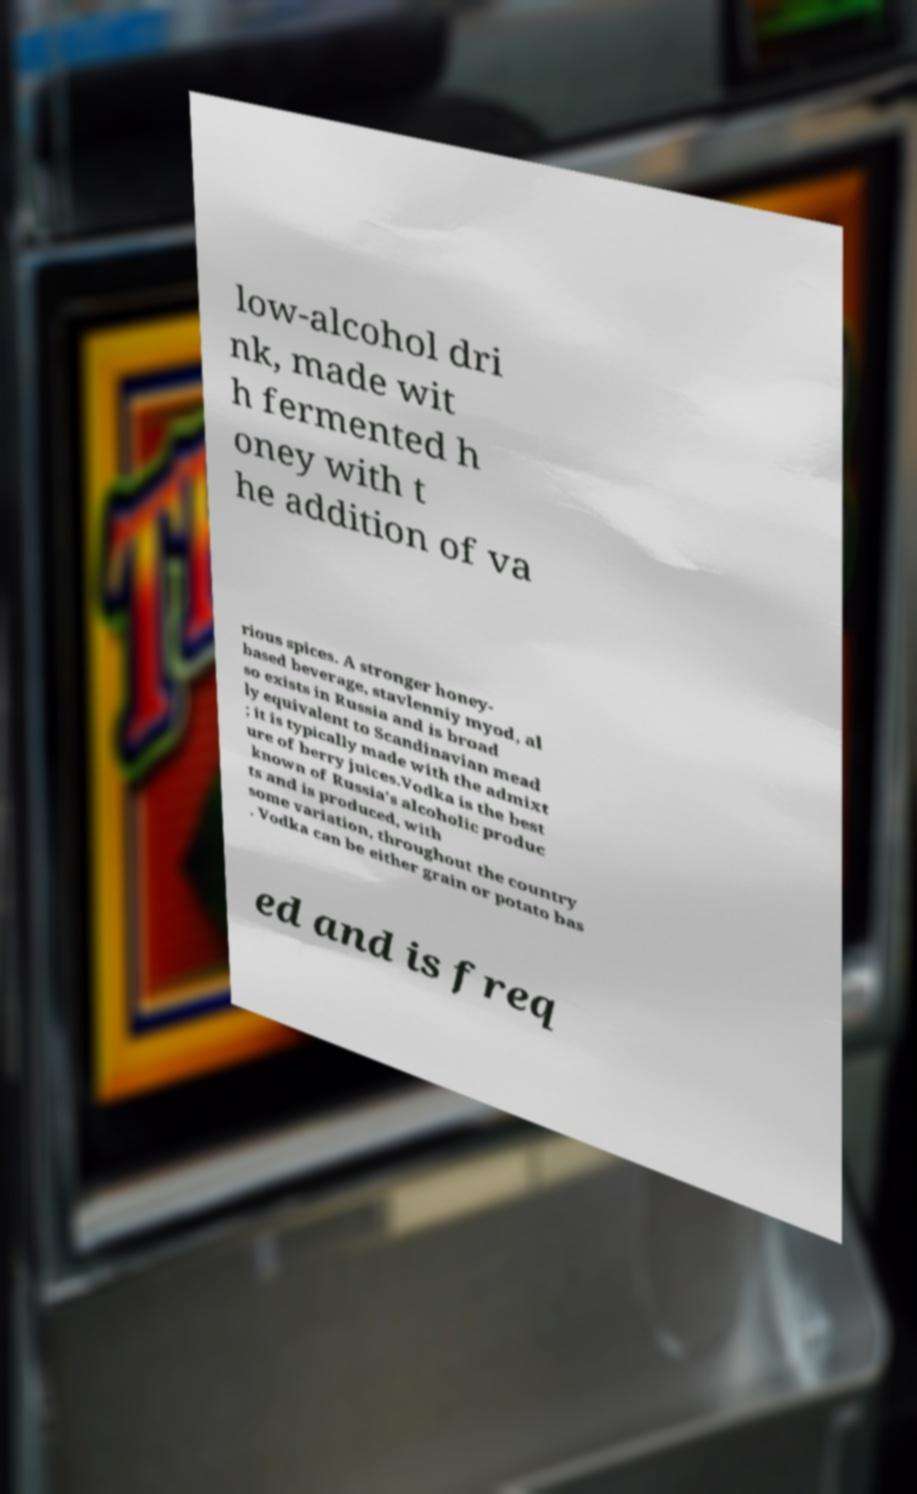Please read and relay the text visible in this image. What does it say? low-alcohol dri nk, made wit h fermented h oney with t he addition of va rious spices. A stronger honey- based beverage, stavlenniy myod, al so exists in Russia and is broad ly equivalent to Scandinavian mead ; it is typically made with the admixt ure of berry juices.Vodka is the best known of Russia's alcoholic produc ts and is produced, with some variation, throughout the country . Vodka can be either grain or potato bas ed and is freq 